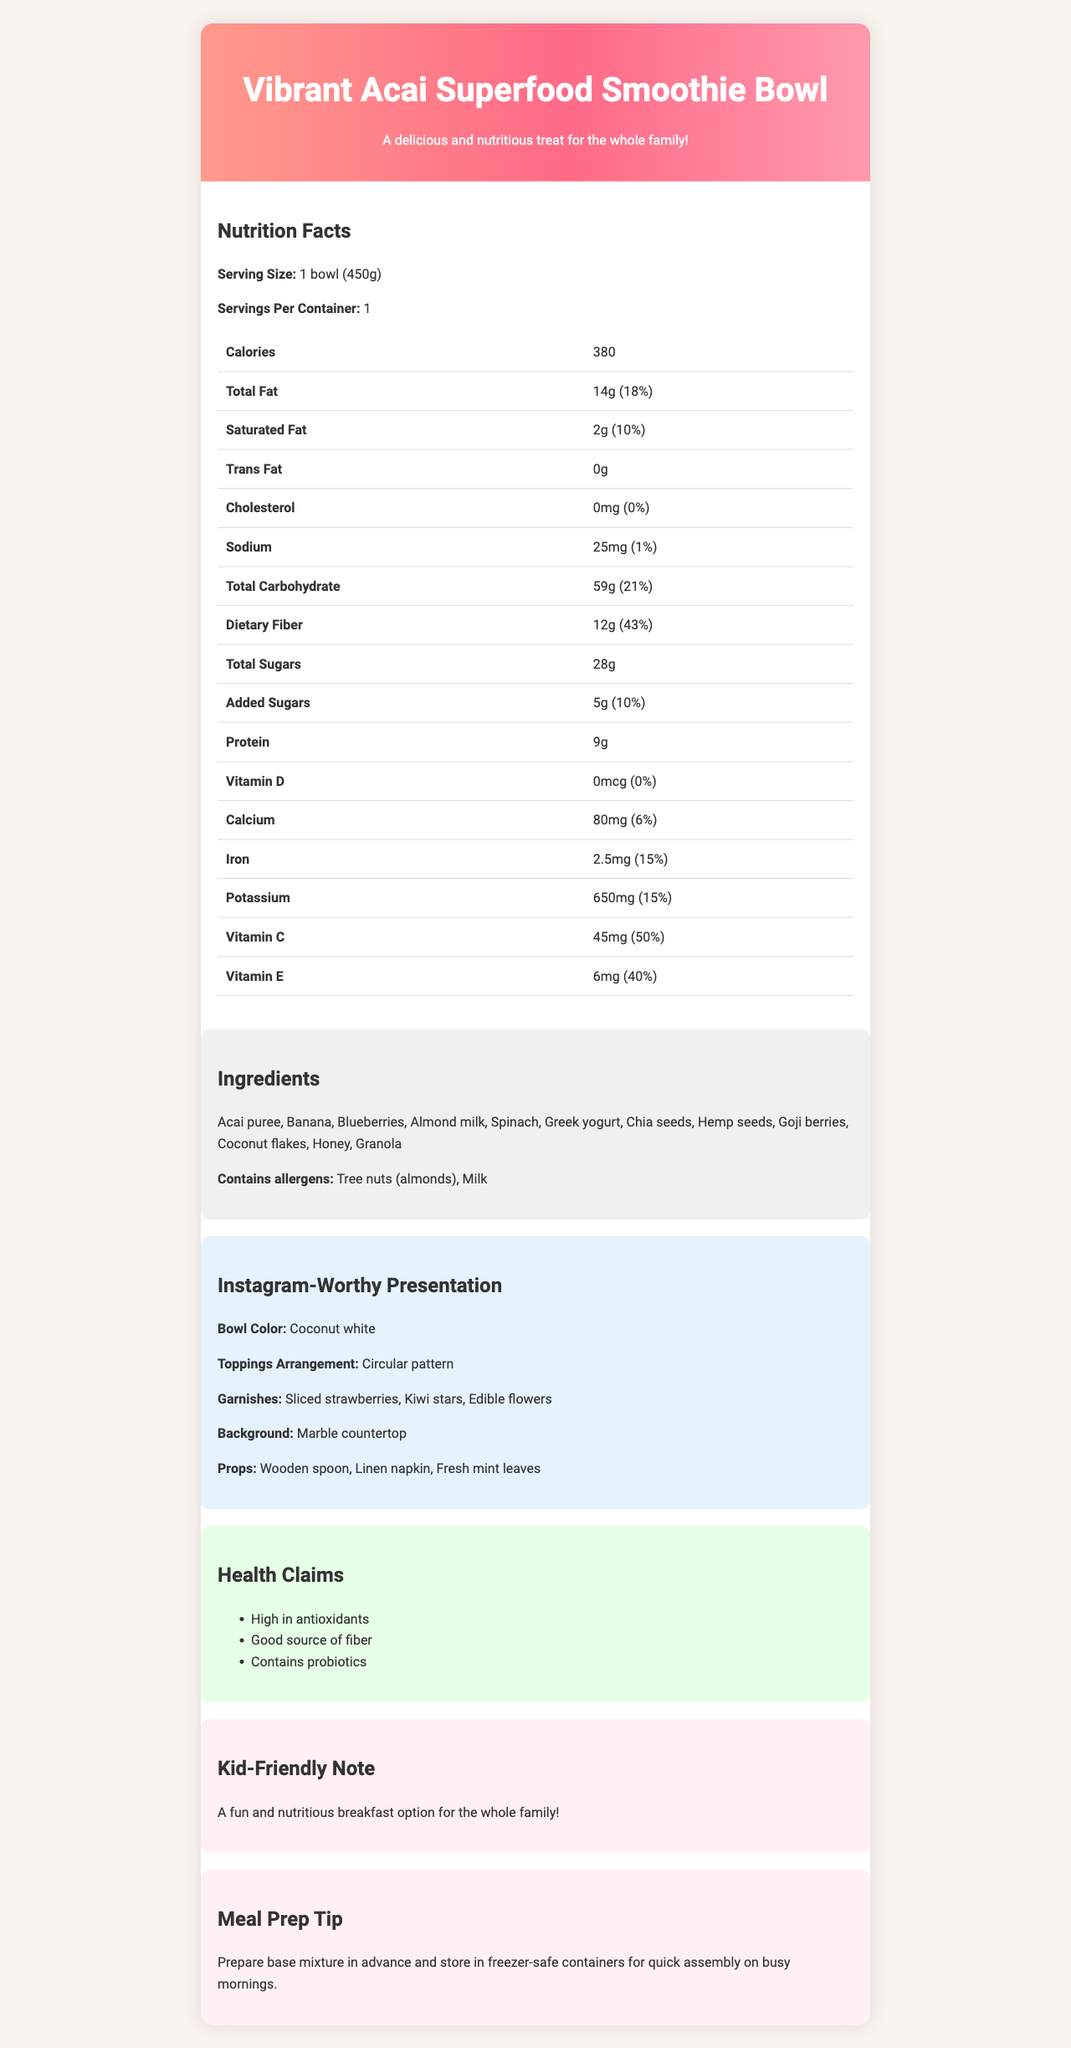what is the serving size of the Vibrant Acai Superfood Smoothie Bowl? The serving size is directly listed in the Nutrition Facts section of the document.
Answer: 1 bowl (450g) how many grams of dietary fiber are in the smoothie bowl? The amount of dietary fiber can be found under the Total Carbohydrate section in the Nutrition Facts.
Answer: 12g what is the daily value percentage of Vitamin C in the smoothie bowl? Under the Nutrition Facts section, the document lists the daily value percentage for Vitamin C as 50%.
Answer: 50% what are the main ingredients in the Vibrant Acai Superfood Smoothie Bowl? The ingredients are listed in the Ingredients section.
Answer: Acai puree, Banana, Blueberries, Almond milk, Spinach, Greek yogurt, Chia seeds, Hemp seeds, Goji berries, Coconut flakes, Honey, Granola how many calories are in one serving of the smoothie bowl? The calorie count is provided at the top of the Nutrition Facts section.
Answer: 380 what are the allergens present in the smoothie bowl? The allergens are listed directly under the Ingredients section.
Answer: Tree nuts (almonds), Milk is the Vibrant Acai Superfood Smoothie Bowl kid-friendly? The document includes a section titled "Kid-Friendly Note" which mentions it is a fun and nutritious breakfast option for the whole family.
Answer: Yes what is the recommended background for an Instagram-worthy presentation of the smoothie bowl? The recommended background is listed under the Instagram-Worthy Presentation section.
Answer: Marble countertop what is the color of the bowl suggested for the Instagram presentation? A. Blue B. Coconut white C. Pastel pink The Instagram-Worthy Presentation section specifies "Coconut white" as the bowl color.
Answer: B how is the toppings arrangement suggested for a good Instagram presentation? A. Randomly scattered B. Linear pattern C. Circular pattern The document specifies that the toppings should be arranged in a circular pattern.
Answer: C how much protein does the smoothie bowl contain? A. 6g B. 9g C. 12g The protein amount is listed as 9g in the Nutrition Facts section.
Answer: B does the smoothie bowl contain any trans fat? The document specifies 0g of trans fat in the Nutrition Facts section.
Answer: No are there any probiotics in the smoothie bowl? One of the health claims listed is "Contains probiotics".
Answer: Yes what are the three garnishes suggested for an Instagram presentation of the smoothie bowl? The garnishes are listed in the Instagram-Worthy Presentation section.
Answer: Sliced strawberries, Kiwi stars, Edible flowers what kind of props are suggested for the Instagram presentation? The props are listed under the Instagram-Worthy Presentation section.
Answer: Wooden spoon, Linen napkin, Fresh mint leaves how many servings are there per container of the smoothie bowl? The servings per container are listed in the Nutrition Facts section.
Answer: 1 how much calcium does one serving of the smoothie bowl provide? The amount of calcium is listed in the Nutrition Facts section.
Answer: 80mg what is the purpose of the meal prep tip provided in the document? The meal prep tip is provided at the end of the document under the Meal Prep Tip section.
Answer: To prepare the base mixture in advance and store it in freezer-safe containers for quick assembly on busy mornings. summarize the entire document. The document features detailed nutritional information, ingredients, allergen information, and health claims. It also offers tips for visually appealing presentation on Instagram, emphasizing key elements such as bowl color, garnishes, and props.
Answer: Vibrant Acai Superfood Smoothie Bowl is a nutritious and Instagram-worthy smoothie bowl. The document provides detailed nutrition facts, ingredients, allergens, and health claims. It also includes suggestions for an Instagram-worthy presentation, highlighting the bowl color, toppings arrangement, garnishes, background, and props. Additionally, a kid-friendly note and meal prep tip are provided. how many grams of total carbohydrates are in the smoothie bowl? The total carbohydrates are listed in the Nutrition Facts section.
Answer: 59g is the smoothie bowl high in antioxidants? "High in antioxidants" is one of the health claims mentioned in the document.
Answer: Yes what is the main idea of the document? The document focuses on the nutritional benefits and Instagram-worthy presentation tips for the smoothie bowl.
Answer: To provide detailed nutritional information and presentation tips for the Vibrant Acai Superfood Smoothie Bowl, making it an attractive, healthy option for families and Instagram influencers. how many grams of sugar are in the smoothie bowl? The total sugars are listed as 28g in the Nutrition Facts section.
Answer: 28g are there any peanut allergens in the smoothie bowl? The document only specifies tree nuts (almonds) and milk as allergens; it does not mention peanuts.
Answer: Cannot be determined 